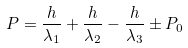<formula> <loc_0><loc_0><loc_500><loc_500>P = \frac { h } { \lambda _ { 1 } } + \frac { h } { \lambda _ { 2 } } - \frac { h } { \lambda _ { 3 } } \pm P _ { 0 }</formula> 